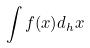<formula> <loc_0><loc_0><loc_500><loc_500>\int f ( x ) d _ { h } x</formula> 